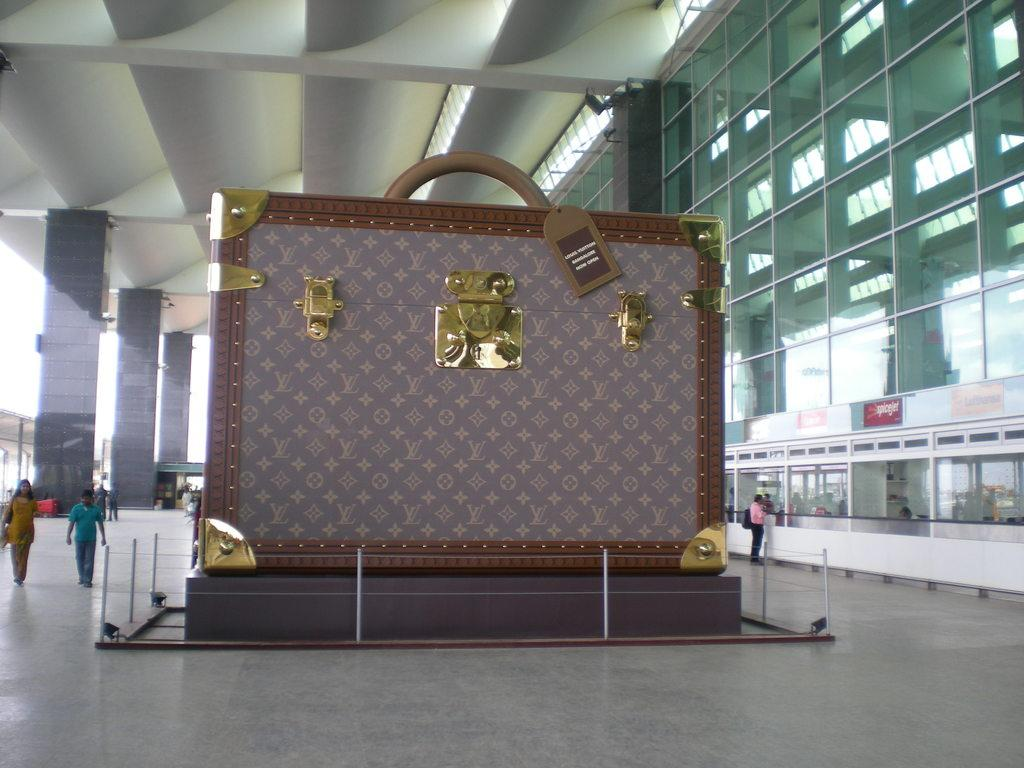What is the most prominent object in the image? There is a huge suitcase in the image. How is the suitcase protected or enclosed? There is a fence around the suitcase. What can be seen on the left side of the image? There are two people walking on the left side of the image. What type of structures are visible in the image? There are poles visible in the image. What type of mouth can be seen on the suitcase in the image? There is no mouth present on the suitcase in the image. What process is being carried out by the eggs in the image? There are no eggs present in the image. 